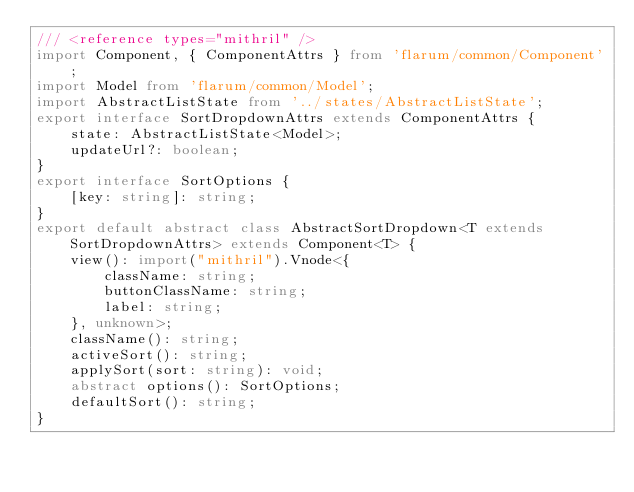Convert code to text. <code><loc_0><loc_0><loc_500><loc_500><_TypeScript_>/// <reference types="mithril" />
import Component, { ComponentAttrs } from 'flarum/common/Component';
import Model from 'flarum/common/Model';
import AbstractListState from '../states/AbstractListState';
export interface SortDropdownAttrs extends ComponentAttrs {
    state: AbstractListState<Model>;
    updateUrl?: boolean;
}
export interface SortOptions {
    [key: string]: string;
}
export default abstract class AbstractSortDropdown<T extends SortDropdownAttrs> extends Component<T> {
    view(): import("mithril").Vnode<{
        className: string;
        buttonClassName: string;
        label: string;
    }, unknown>;
    className(): string;
    activeSort(): string;
    applySort(sort: string): void;
    abstract options(): SortOptions;
    defaultSort(): string;
}
</code> 